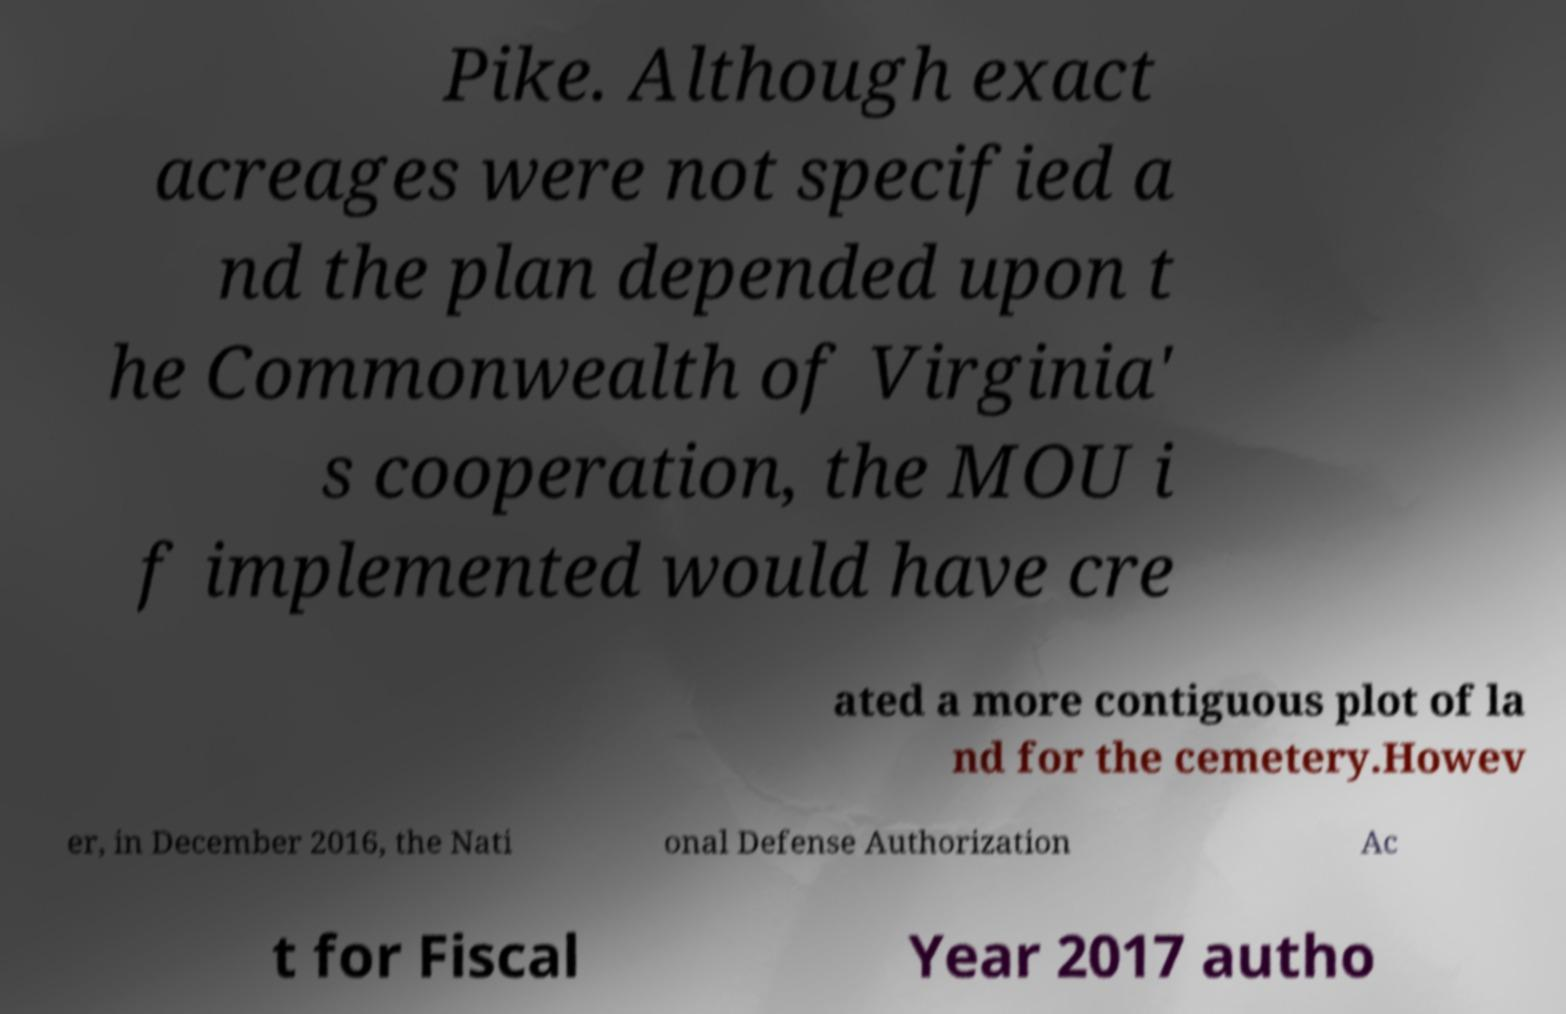There's text embedded in this image that I need extracted. Can you transcribe it verbatim? Pike. Although exact acreages were not specified a nd the plan depended upon t he Commonwealth of Virginia' s cooperation, the MOU i f implemented would have cre ated a more contiguous plot of la nd for the cemetery.Howev er, in December 2016, the Nati onal Defense Authorization Ac t for Fiscal Year 2017 autho 